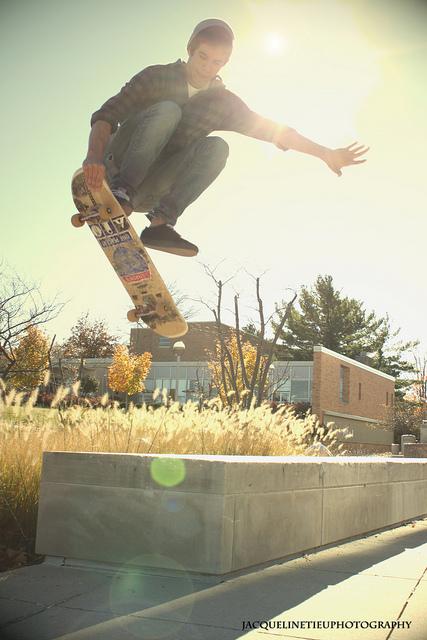How high up is he?
Write a very short answer. 3 feet. What did he jump off of?
Quick response, please. Wall. Which hand is the person holding out?
Concise answer only. Left. Is this kid defying gravity?
Be succinct. Yes. What is the design on his shirt called?
Answer briefly. Striped. Is the person wearing protective gear?
Short answer required. No. Does he look like an expert?
Write a very short answer. Yes. Which arm is higher in the air?
Answer briefly. Left. How many weeds is the skateboarder flying over?
Short answer required. Many. Is this boy flying?
Answer briefly. No. Will this person land safely?
Give a very brief answer. Yes. 